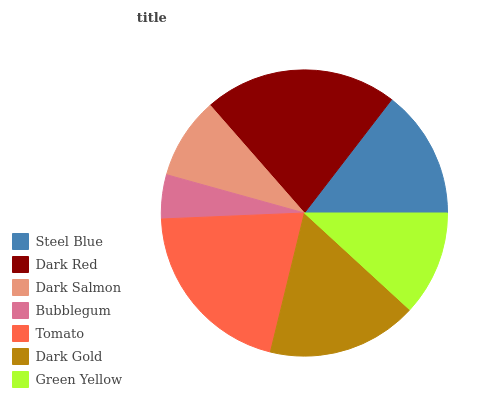Is Bubblegum the minimum?
Answer yes or no. Yes. Is Dark Red the maximum?
Answer yes or no. Yes. Is Dark Salmon the minimum?
Answer yes or no. No. Is Dark Salmon the maximum?
Answer yes or no. No. Is Dark Red greater than Dark Salmon?
Answer yes or no. Yes. Is Dark Salmon less than Dark Red?
Answer yes or no. Yes. Is Dark Salmon greater than Dark Red?
Answer yes or no. No. Is Dark Red less than Dark Salmon?
Answer yes or no. No. Is Steel Blue the high median?
Answer yes or no. Yes. Is Steel Blue the low median?
Answer yes or no. Yes. Is Dark Gold the high median?
Answer yes or no. No. Is Dark Red the low median?
Answer yes or no. No. 